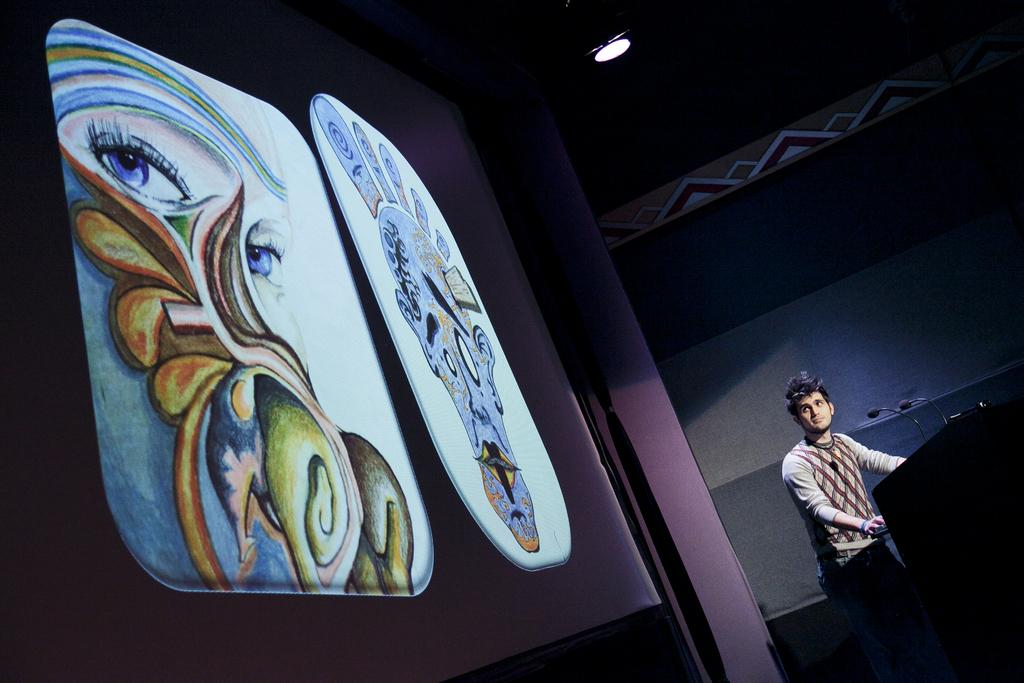What is the person in the image doing? There is a person standing in front of the podium. What is on the podium? The podium has mics on it. What is located to the left of the podium? There is a screen to the left of the podium. What can be seen at the top of the image? There is a light at the top of the image. What type of knife is the person using to read from the screen? There is no knife present in the image, and the person is not reading from the screen. 